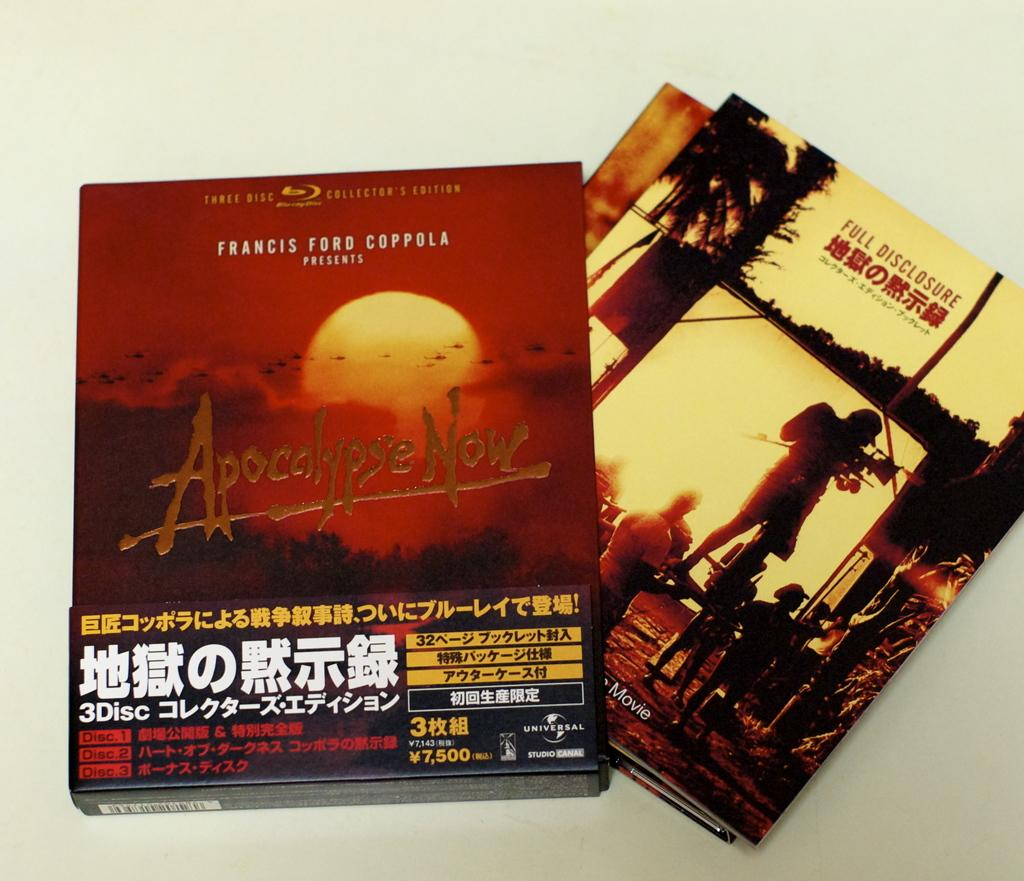Provide a one-sentence caption for the provided image. a box of magazines titled ' apocolypse now' on the cover. 